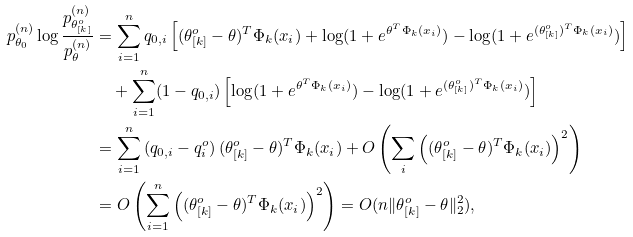Convert formula to latex. <formula><loc_0><loc_0><loc_500><loc_500>p _ { \theta _ { 0 } } ^ { ( n ) } \log \frac { p _ { \theta _ { [ k ] } ^ { o } } ^ { ( n ) } } { p _ { \theta } ^ { ( n ) } } & = \sum _ { i = 1 } ^ { n } q _ { 0 , i } \left [ ( \theta _ { [ k ] } ^ { o } - \theta ) ^ { T } \Phi _ { k } ( x _ { i } ) + \log ( 1 + e ^ { \theta ^ { T } \Phi _ { k } ( x _ { i } ) } ) - \log ( 1 + e ^ { ( \theta _ { [ k ] } ^ { o } ) ^ { T } \Phi _ { k } ( x _ { i } ) } ) \right ] \\ & \quad + \sum _ { i = 1 } ^ { n } ( 1 - q _ { 0 , i } ) \left [ \log ( 1 + e ^ { \theta ^ { T } \Phi _ { k } ( x _ { i } ) } ) - \log ( 1 + e ^ { ( \theta _ { [ k ] } ^ { o } ) ^ { T } \Phi _ { k } ( x _ { i } ) } ) \right ] \\ & = \sum _ { i = 1 } ^ { n } \left ( q _ { 0 , i } - q ^ { o } _ { i } \right ) ( \theta _ { [ k ] } ^ { o } - \theta ) ^ { T } \Phi _ { k } ( x _ { i } ) + O \left ( \sum _ { i } \left ( ( \theta _ { [ k ] } ^ { o } - \theta ) ^ { T } \Phi _ { k } ( x _ { i } ) \right ) ^ { 2 } \right ) \\ & = O \left ( \sum _ { i = 1 } ^ { n } \left ( ( \theta _ { [ k ] } ^ { o } - \theta ) ^ { T } \Phi _ { k } ( x _ { i } ) \right ) ^ { 2 } \right ) = O ( n \| \theta _ { [ k ] } ^ { o } - \theta \| _ { 2 } ^ { 2 } ) ,</formula> 